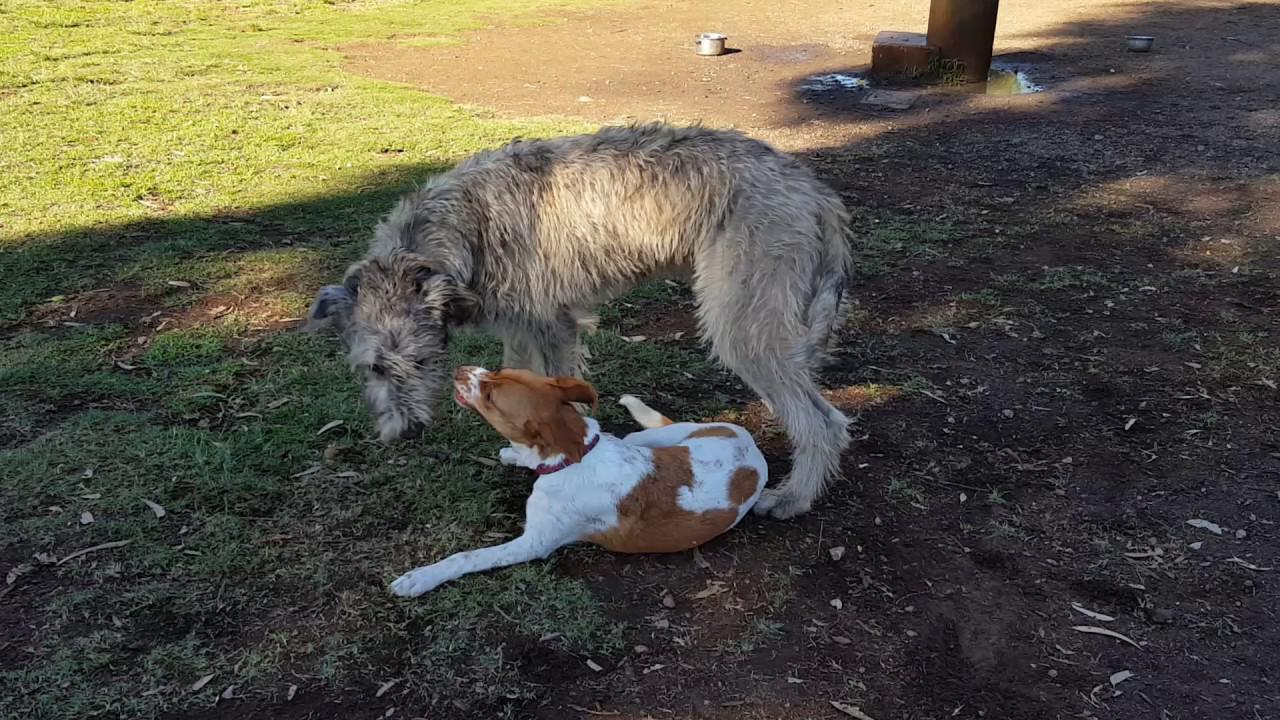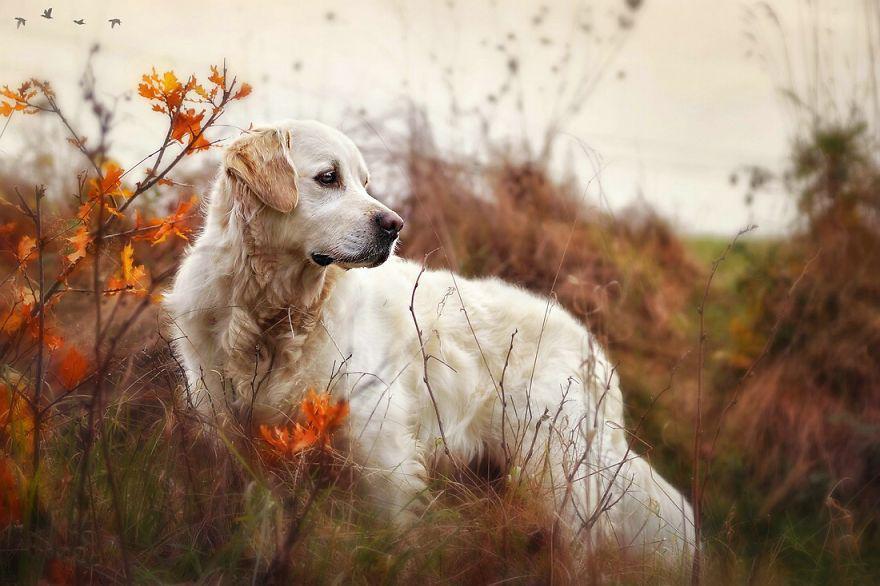The first image is the image on the left, the second image is the image on the right. Evaluate the accuracy of this statement regarding the images: "The left and right image contains the same number of dogs with their bodies facing right.". Is it true? Answer yes or no. No. The first image is the image on the left, the second image is the image on the right. Considering the images on both sides, is "Two dogs are laying down." valid? Answer yes or no. No. 